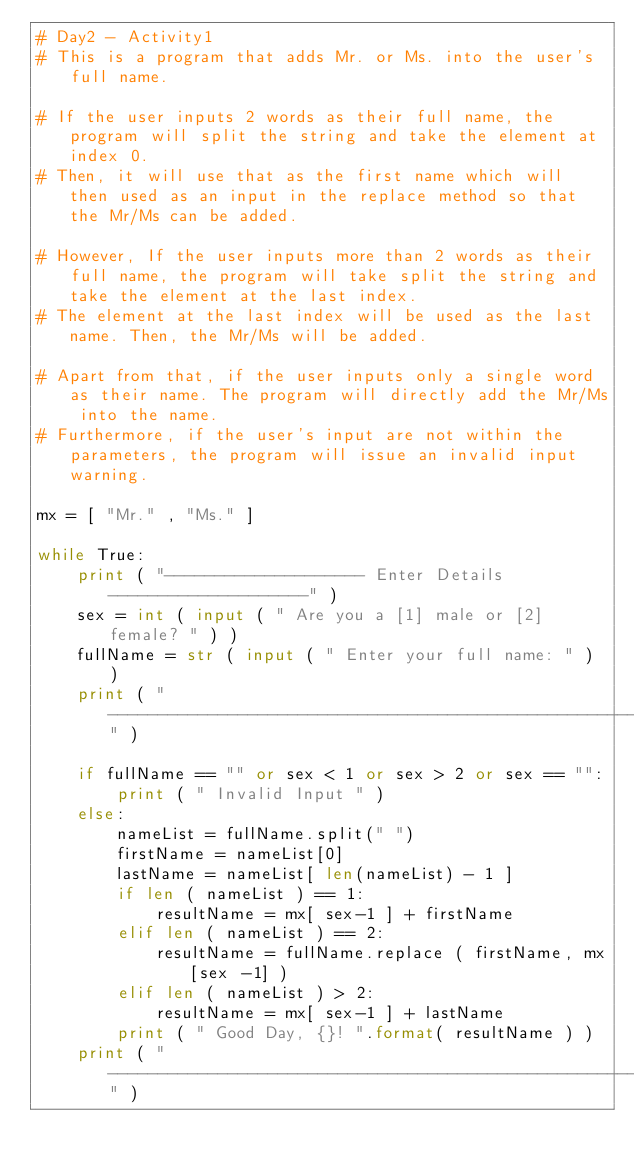<code> <loc_0><loc_0><loc_500><loc_500><_Python_># Day2 - Activity1
# This is a program that adds Mr. or Ms. into the user's full name.

# If the user inputs 2 words as their full name, the program will split the string and take the element at index 0.
# Then, it will use that as the first name which will then used as an input in the replace method so that the Mr/Ms can be added.

# However, If the user inputs more than 2 words as their full name, the program will take split the string and take the element at the last index.
# The element at the last index will be used as the last name. Then, the Mr/Ms will be added.

# Apart from that, if the user inputs only a single word as their name. The program will directly add the Mr/Ms into the name.
# Furthermore, if the user's input are not within the parameters, the program will issue an invalid input warning.

mx = [ "Mr." , "Ms." ]

while True:
    print ( "-------------------- Enter Details --------------------" )
    sex = int ( input ( " Are you a [1] male or [2] female? " ) )
    fullName = str ( input ( " Enter your full name: " ) )
    print ( "-------------------------------------------------------" )

    if fullName == "" or sex < 1 or sex > 2 or sex == "":
        print ( " Invalid Input " )
    else:
        nameList = fullName.split(" ")
        firstName = nameList[0]
        lastName = nameList[ len(nameList) - 1 ]
        if len ( nameList ) == 1:
            resultName = mx[ sex-1 ] + firstName
        elif len ( nameList ) == 2:
            resultName = fullName.replace ( firstName, mx[sex -1] )
        elif len ( nameList ) > 2:
            resultName = mx[ sex-1 ] + lastName
        print ( " Good Day, {}! ".format( resultName ) )
    print ( "-------------------------------------------------------" )

    
    
</code> 